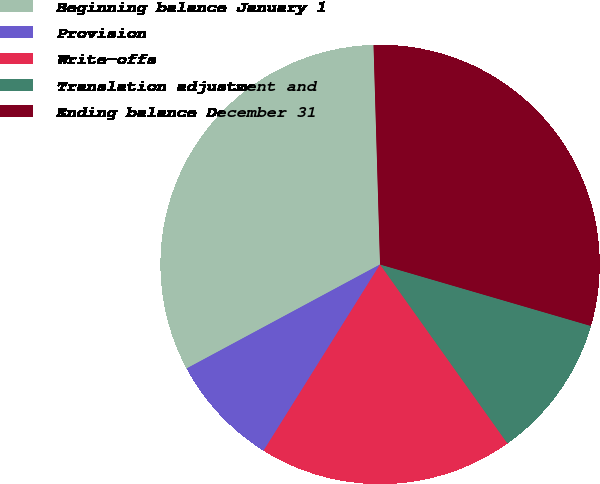Convert chart. <chart><loc_0><loc_0><loc_500><loc_500><pie_chart><fcel>Beginning balance January 1<fcel>Provision<fcel>Write-offs<fcel>Translation adjustment and<fcel>Ending balance December 31<nl><fcel>32.38%<fcel>8.25%<fcel>18.74%<fcel>10.64%<fcel>29.99%<nl></chart> 